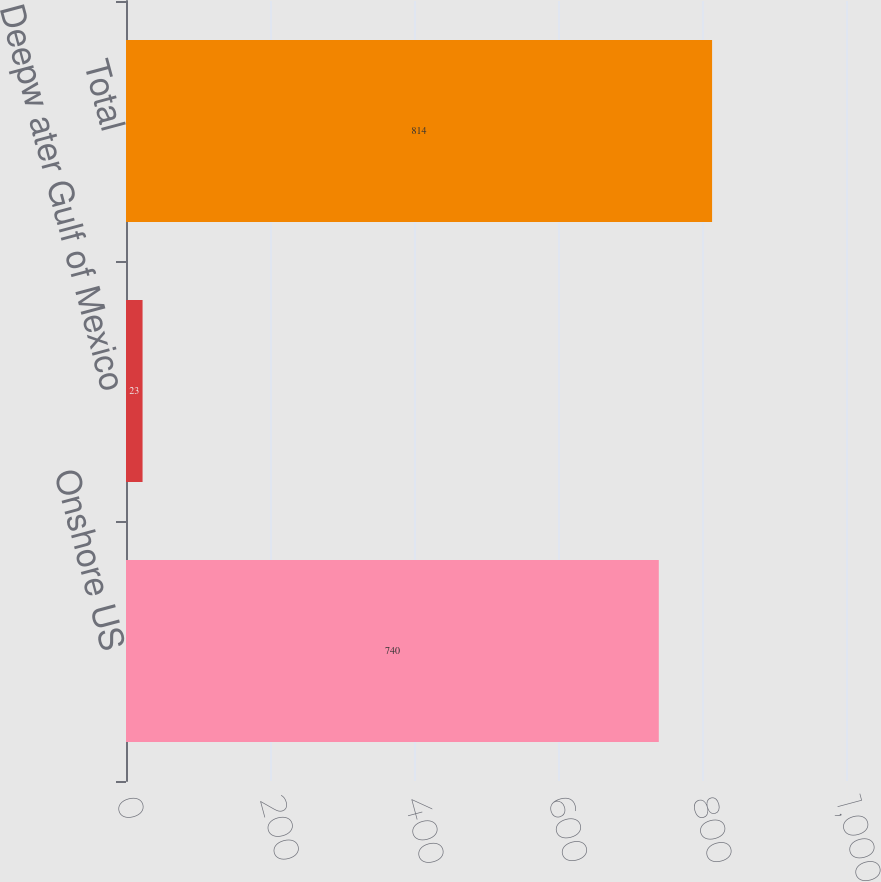Convert chart to OTSL. <chart><loc_0><loc_0><loc_500><loc_500><bar_chart><fcel>Onshore US<fcel>Deepw ater Gulf of Mexico<fcel>Total<nl><fcel>740<fcel>23<fcel>814<nl></chart> 